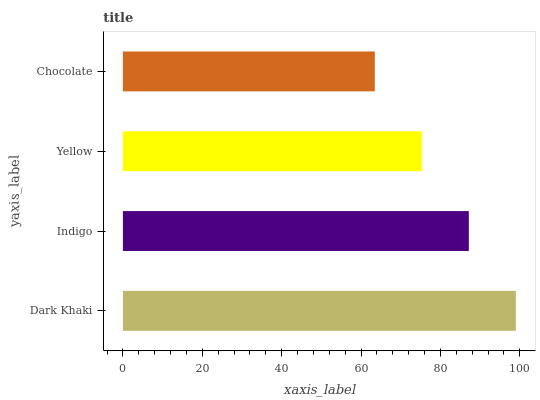Is Chocolate the minimum?
Answer yes or no. Yes. Is Dark Khaki the maximum?
Answer yes or no. Yes. Is Indigo the minimum?
Answer yes or no. No. Is Indigo the maximum?
Answer yes or no. No. Is Dark Khaki greater than Indigo?
Answer yes or no. Yes. Is Indigo less than Dark Khaki?
Answer yes or no. Yes. Is Indigo greater than Dark Khaki?
Answer yes or no. No. Is Dark Khaki less than Indigo?
Answer yes or no. No. Is Indigo the high median?
Answer yes or no. Yes. Is Yellow the low median?
Answer yes or no. Yes. Is Yellow the high median?
Answer yes or no. No. Is Indigo the low median?
Answer yes or no. No. 